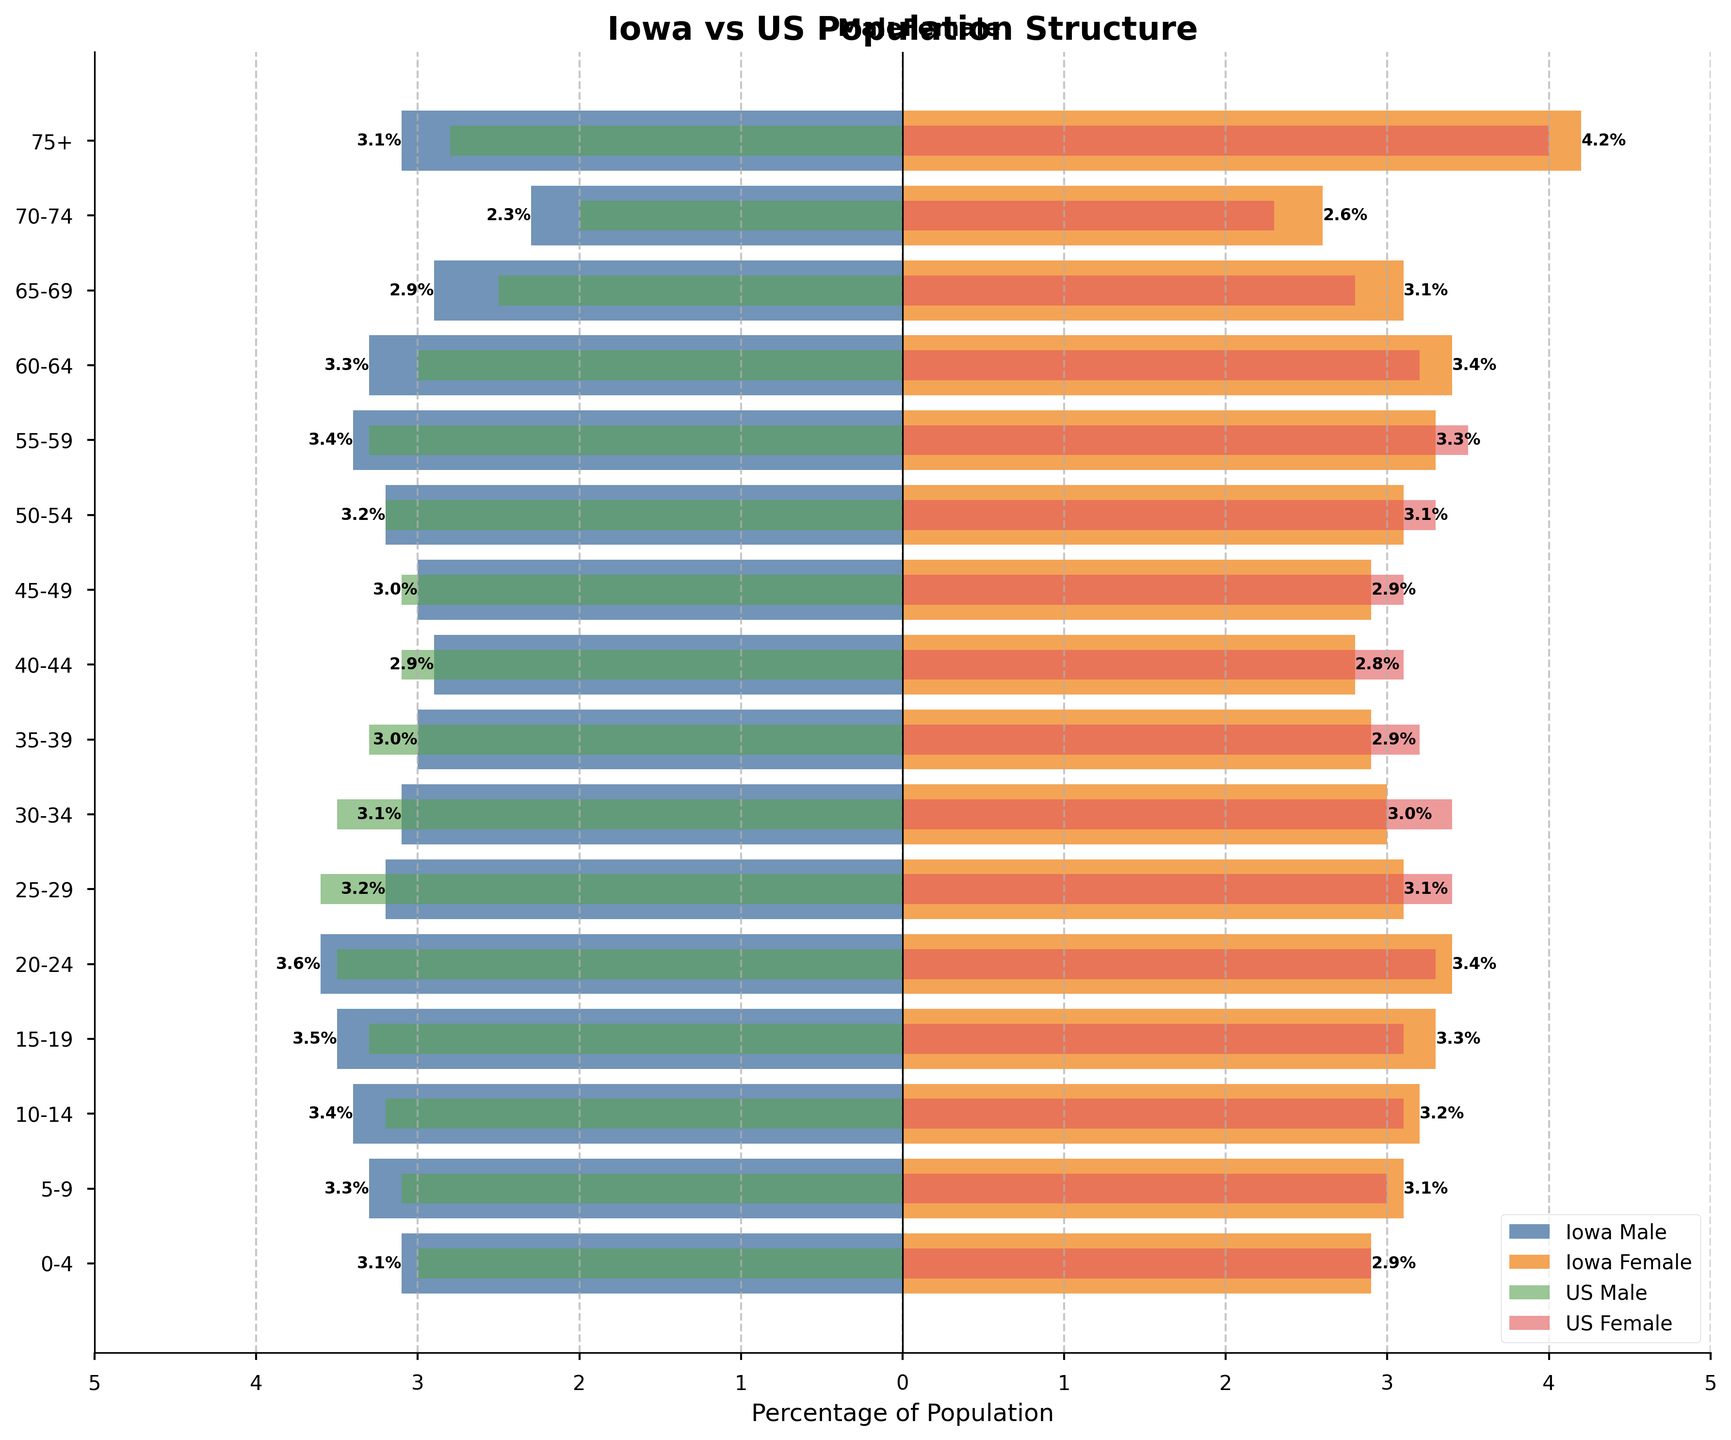What is the most populated age group in Iowa for both males and females? By looking at the longest bars for both males (left bars) and females (right bars), we see that the 15-19 age group has the highest percentages for both with 3.5% for males and 3.3% for females.
Answer: 15-19 How does the percentage of Iowa males aged 0-4 compare to the national average? The Iowa male percentage for ages 0-4 is 3.1%, while the national average for the same age group is 3.0%. The Iowa percentage is thus 0.1% higher than the national average.
Answer: 0.1% higher Which age group has the largest difference in the population percentage between Iowa males and females? By examining the bars for each age group, the largest difference appears in the 75+ age group. For Iowa, the percentages are 3.1% for males and 4.2% for females, making the difference 1.1%.
Answer: 75+ What is the combined percentage of Iowa females aged 25-34? Adding the percentages for females aged 25-29 (3.1%) and 30-34 (3.0%), we get 3.1% + 3.0% = 6.1%.
Answer: 6.1% Are there any age groups where the national male percentage is higher than the Iowa male percentage? By comparing the Iowa and national male percentages for each age group, we find that for the 25-29 age group, the national percentage (3.6%) is higher than Iowa’s (3.2%).
Answer: 25-29 Which age group has the closest population percentages between Iowa males and US males? Checking the values, the 10-14 age group where Iowa males are 3.4% and US males are 3.2% shows the smallest difference of 0.2%.
Answer: 10-14 Does the gender composition of the 70-74 age group differ more in Iowa or nationally? For the 70-74 age group in Iowa, the percentages are 2.3% for males and 2.6% for females, a difference of 0.3%. National values are 2.0% for males and 2.3% for females, also a difference of 0.3%. Thus, the difference is the same in both.
Answer: Same Looking at the plot, which gender has a higher percentage in the 55-59 age group in Iowa? The plot shows that Iowa females (3.3%) have a slightly lower percentage than males (3.4%) in the 55-59 age group.
Answer: Males For the age group 65-69, what is the difference between Iowa and US female percentages? The plot indicates that in Iowa, the percentage is 3.1% for females aged 65-69, while the national percentage is 2.8%. The difference is 3.1% - 2.8% = 0.3%.
Answer: 0.3% How does the gender composition for ages 20-24 in Iowa compare to the US? For ages 20-24, Iowa males (3.6%) and females (3.4%) both have slightly higher percentages than the national averages of 3.5% for males and 3.3% for females.
Answer: Slightly higher in Iowa 